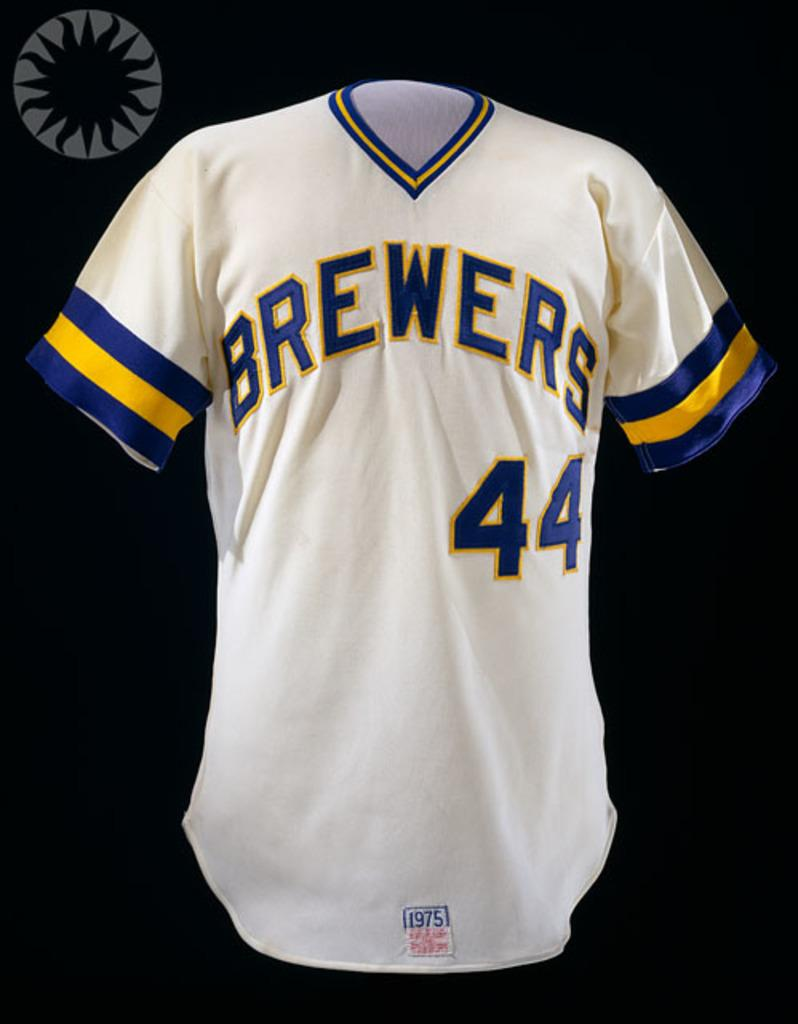What is the main feature in the middle of the image? There is a white color text in the middle of the image. What can be found within the white text? The text contains other texts and numbers. Where is the watermark located in the image? The watermark is on the top left of the image. How would you describe the background of the image? The background of the image is dark in color. What type of store can be seen in the image? There is no store present in the image; it features a white text with other texts and numbers on a dark background. How many buttons are visible on the text in the image? There are no buttons visible on the text in the image. 